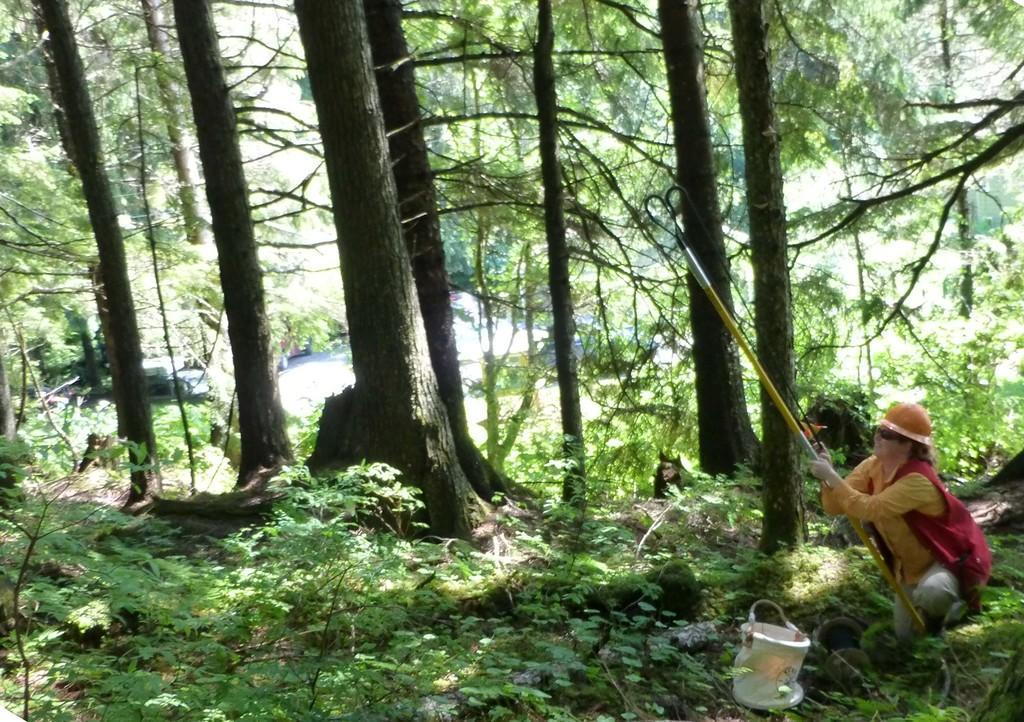In one or two sentences, can you explain what this image depicts? In the image there are many trees, plants and on the right side there is a woman, she is holding a stick and beside the woman there is a basket. 